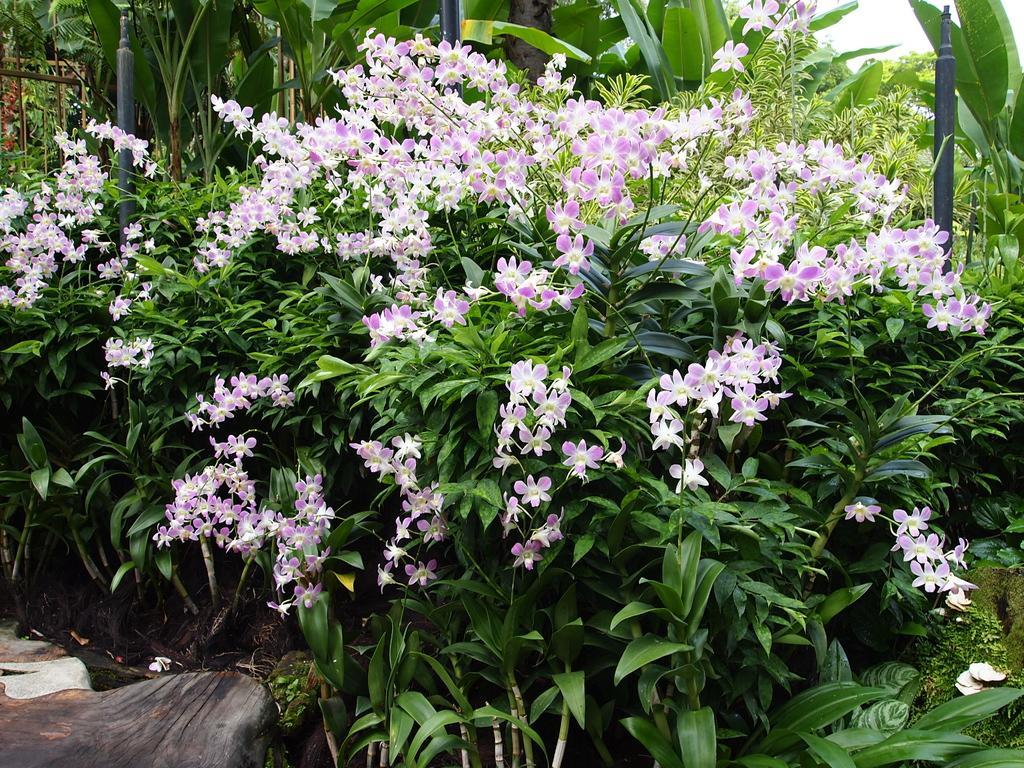How would you summarize this image in a sentence or two? In this image there are flowers and plants. In the background of the image there are trees. 